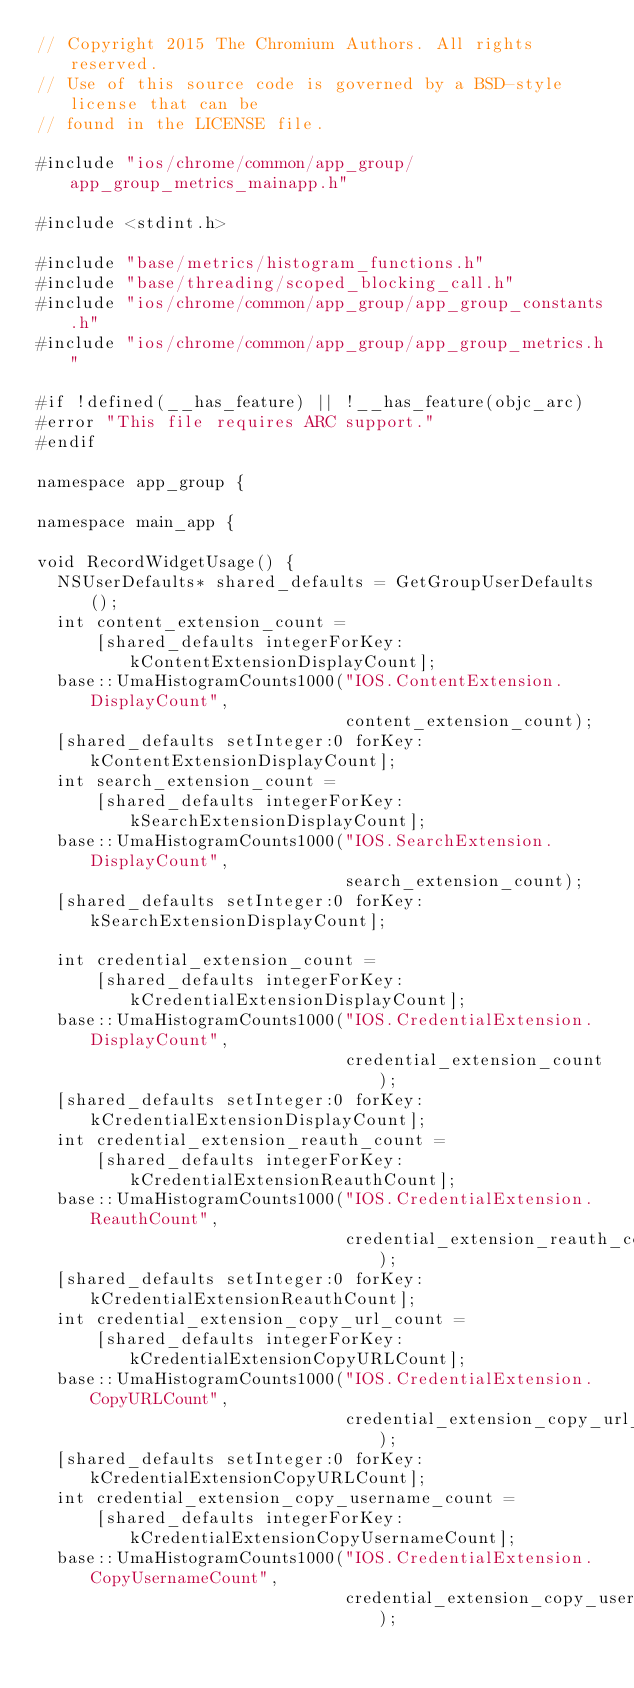Convert code to text. <code><loc_0><loc_0><loc_500><loc_500><_ObjectiveC_>// Copyright 2015 The Chromium Authors. All rights reserved.
// Use of this source code is governed by a BSD-style license that can be
// found in the LICENSE file.

#include "ios/chrome/common/app_group/app_group_metrics_mainapp.h"

#include <stdint.h>

#include "base/metrics/histogram_functions.h"
#include "base/threading/scoped_blocking_call.h"
#include "ios/chrome/common/app_group/app_group_constants.h"
#include "ios/chrome/common/app_group/app_group_metrics.h"

#if !defined(__has_feature) || !__has_feature(objc_arc)
#error "This file requires ARC support."
#endif

namespace app_group {

namespace main_app {

void RecordWidgetUsage() {
  NSUserDefaults* shared_defaults = GetGroupUserDefaults();
  int content_extension_count =
      [shared_defaults integerForKey:kContentExtensionDisplayCount];
  base::UmaHistogramCounts1000("IOS.ContentExtension.DisplayCount",
                               content_extension_count);
  [shared_defaults setInteger:0 forKey:kContentExtensionDisplayCount];
  int search_extension_count =
      [shared_defaults integerForKey:kSearchExtensionDisplayCount];
  base::UmaHistogramCounts1000("IOS.SearchExtension.DisplayCount",
                               search_extension_count);
  [shared_defaults setInteger:0 forKey:kSearchExtensionDisplayCount];

  int credential_extension_count =
      [shared_defaults integerForKey:kCredentialExtensionDisplayCount];
  base::UmaHistogramCounts1000("IOS.CredentialExtension.DisplayCount",
                               credential_extension_count);
  [shared_defaults setInteger:0 forKey:kCredentialExtensionDisplayCount];
  int credential_extension_reauth_count =
      [shared_defaults integerForKey:kCredentialExtensionReauthCount];
  base::UmaHistogramCounts1000("IOS.CredentialExtension.ReauthCount",
                               credential_extension_reauth_count);
  [shared_defaults setInteger:0 forKey:kCredentialExtensionReauthCount];
  int credential_extension_copy_url_count =
      [shared_defaults integerForKey:kCredentialExtensionCopyURLCount];
  base::UmaHistogramCounts1000("IOS.CredentialExtension.CopyURLCount",
                               credential_extension_copy_url_count);
  [shared_defaults setInteger:0 forKey:kCredentialExtensionCopyURLCount];
  int credential_extension_copy_username_count =
      [shared_defaults integerForKey:kCredentialExtensionCopyUsernameCount];
  base::UmaHistogramCounts1000("IOS.CredentialExtension.CopyUsernameCount",
                               credential_extension_copy_username_count);</code> 